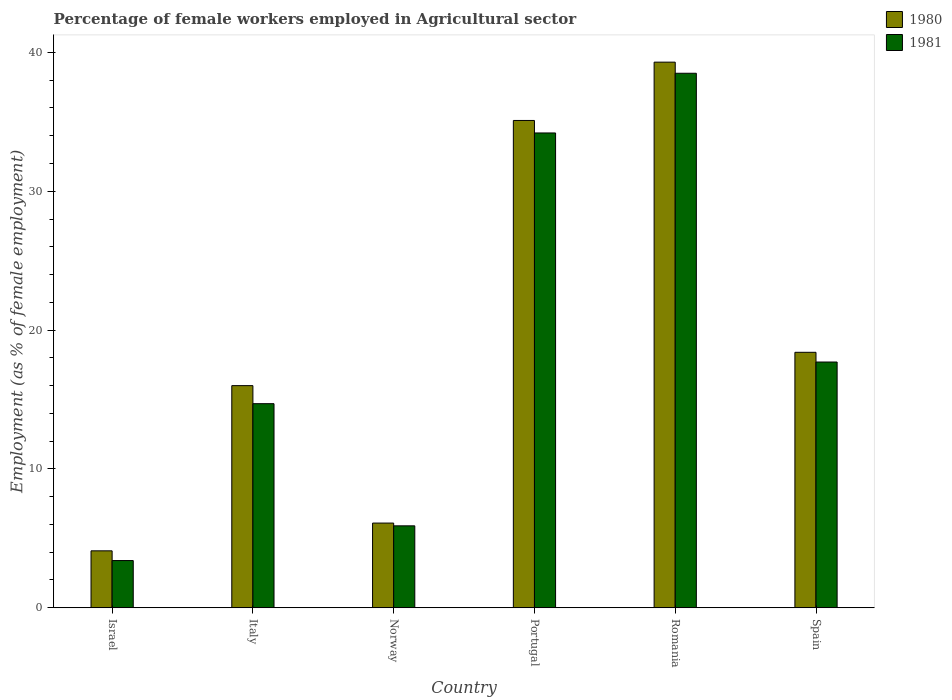Are the number of bars per tick equal to the number of legend labels?
Give a very brief answer. Yes. What is the label of the 4th group of bars from the left?
Offer a terse response. Portugal. What is the percentage of females employed in Agricultural sector in 1981 in Romania?
Make the answer very short. 38.5. Across all countries, what is the maximum percentage of females employed in Agricultural sector in 1981?
Keep it short and to the point. 38.5. Across all countries, what is the minimum percentage of females employed in Agricultural sector in 1980?
Keep it short and to the point. 4.1. In which country was the percentage of females employed in Agricultural sector in 1980 maximum?
Keep it short and to the point. Romania. What is the total percentage of females employed in Agricultural sector in 1980 in the graph?
Offer a very short reply. 119. What is the difference between the percentage of females employed in Agricultural sector in 1980 in Italy and that in Norway?
Your answer should be very brief. 9.9. What is the difference between the percentage of females employed in Agricultural sector in 1980 in Romania and the percentage of females employed in Agricultural sector in 1981 in Norway?
Your response must be concise. 33.4. What is the average percentage of females employed in Agricultural sector in 1981 per country?
Give a very brief answer. 19.07. What is the difference between the percentage of females employed in Agricultural sector of/in 1980 and percentage of females employed in Agricultural sector of/in 1981 in Spain?
Give a very brief answer. 0.7. What is the ratio of the percentage of females employed in Agricultural sector in 1981 in Italy to that in Portugal?
Provide a succinct answer. 0.43. Is the percentage of females employed in Agricultural sector in 1981 in Israel less than that in Italy?
Ensure brevity in your answer.  Yes. What is the difference between the highest and the second highest percentage of females employed in Agricultural sector in 1980?
Provide a succinct answer. -16.7. What is the difference between the highest and the lowest percentage of females employed in Agricultural sector in 1980?
Provide a short and direct response. 35.2. What does the 2nd bar from the left in Italy represents?
Your answer should be very brief. 1981. What does the 2nd bar from the right in Romania represents?
Your answer should be compact. 1980. Are all the bars in the graph horizontal?
Your answer should be compact. No. How many countries are there in the graph?
Provide a short and direct response. 6. What is the difference between two consecutive major ticks on the Y-axis?
Provide a succinct answer. 10. Does the graph contain any zero values?
Offer a very short reply. No. Where does the legend appear in the graph?
Give a very brief answer. Top right. How many legend labels are there?
Ensure brevity in your answer.  2. What is the title of the graph?
Ensure brevity in your answer.  Percentage of female workers employed in Agricultural sector. Does "1974" appear as one of the legend labels in the graph?
Offer a terse response. No. What is the label or title of the X-axis?
Offer a very short reply. Country. What is the label or title of the Y-axis?
Your answer should be compact. Employment (as % of female employment). What is the Employment (as % of female employment) in 1980 in Israel?
Your answer should be very brief. 4.1. What is the Employment (as % of female employment) of 1981 in Israel?
Ensure brevity in your answer.  3.4. What is the Employment (as % of female employment) of 1981 in Italy?
Your response must be concise. 14.7. What is the Employment (as % of female employment) in 1980 in Norway?
Your response must be concise. 6.1. What is the Employment (as % of female employment) in 1981 in Norway?
Give a very brief answer. 5.9. What is the Employment (as % of female employment) in 1980 in Portugal?
Offer a very short reply. 35.1. What is the Employment (as % of female employment) of 1981 in Portugal?
Provide a short and direct response. 34.2. What is the Employment (as % of female employment) in 1980 in Romania?
Offer a terse response. 39.3. What is the Employment (as % of female employment) in 1981 in Romania?
Make the answer very short. 38.5. What is the Employment (as % of female employment) in 1980 in Spain?
Keep it short and to the point. 18.4. What is the Employment (as % of female employment) in 1981 in Spain?
Keep it short and to the point. 17.7. Across all countries, what is the maximum Employment (as % of female employment) of 1980?
Provide a short and direct response. 39.3. Across all countries, what is the maximum Employment (as % of female employment) in 1981?
Your answer should be compact. 38.5. Across all countries, what is the minimum Employment (as % of female employment) in 1980?
Your answer should be very brief. 4.1. Across all countries, what is the minimum Employment (as % of female employment) in 1981?
Your answer should be very brief. 3.4. What is the total Employment (as % of female employment) in 1980 in the graph?
Your answer should be compact. 119. What is the total Employment (as % of female employment) in 1981 in the graph?
Give a very brief answer. 114.4. What is the difference between the Employment (as % of female employment) in 1980 in Israel and that in Italy?
Give a very brief answer. -11.9. What is the difference between the Employment (as % of female employment) of 1981 in Israel and that in Norway?
Your answer should be compact. -2.5. What is the difference between the Employment (as % of female employment) of 1980 in Israel and that in Portugal?
Ensure brevity in your answer.  -31. What is the difference between the Employment (as % of female employment) in 1981 in Israel and that in Portugal?
Your answer should be very brief. -30.8. What is the difference between the Employment (as % of female employment) of 1980 in Israel and that in Romania?
Keep it short and to the point. -35.2. What is the difference between the Employment (as % of female employment) in 1981 in Israel and that in Romania?
Your answer should be very brief. -35.1. What is the difference between the Employment (as % of female employment) of 1980 in Israel and that in Spain?
Make the answer very short. -14.3. What is the difference between the Employment (as % of female employment) in 1981 in Israel and that in Spain?
Provide a short and direct response. -14.3. What is the difference between the Employment (as % of female employment) in 1980 in Italy and that in Norway?
Your answer should be very brief. 9.9. What is the difference between the Employment (as % of female employment) of 1981 in Italy and that in Norway?
Your answer should be very brief. 8.8. What is the difference between the Employment (as % of female employment) in 1980 in Italy and that in Portugal?
Offer a very short reply. -19.1. What is the difference between the Employment (as % of female employment) in 1981 in Italy and that in Portugal?
Offer a very short reply. -19.5. What is the difference between the Employment (as % of female employment) in 1980 in Italy and that in Romania?
Provide a short and direct response. -23.3. What is the difference between the Employment (as % of female employment) in 1981 in Italy and that in Romania?
Offer a very short reply. -23.8. What is the difference between the Employment (as % of female employment) in 1980 in Italy and that in Spain?
Give a very brief answer. -2.4. What is the difference between the Employment (as % of female employment) in 1981 in Italy and that in Spain?
Ensure brevity in your answer.  -3. What is the difference between the Employment (as % of female employment) of 1981 in Norway and that in Portugal?
Provide a succinct answer. -28.3. What is the difference between the Employment (as % of female employment) in 1980 in Norway and that in Romania?
Make the answer very short. -33.2. What is the difference between the Employment (as % of female employment) of 1981 in Norway and that in Romania?
Keep it short and to the point. -32.6. What is the difference between the Employment (as % of female employment) in 1980 in Norway and that in Spain?
Your response must be concise. -12.3. What is the difference between the Employment (as % of female employment) of 1981 in Norway and that in Spain?
Offer a very short reply. -11.8. What is the difference between the Employment (as % of female employment) in 1980 in Portugal and that in Romania?
Your response must be concise. -4.2. What is the difference between the Employment (as % of female employment) in 1980 in Romania and that in Spain?
Offer a very short reply. 20.9. What is the difference between the Employment (as % of female employment) of 1981 in Romania and that in Spain?
Keep it short and to the point. 20.8. What is the difference between the Employment (as % of female employment) in 1980 in Israel and the Employment (as % of female employment) in 1981 in Norway?
Keep it short and to the point. -1.8. What is the difference between the Employment (as % of female employment) in 1980 in Israel and the Employment (as % of female employment) in 1981 in Portugal?
Offer a terse response. -30.1. What is the difference between the Employment (as % of female employment) in 1980 in Israel and the Employment (as % of female employment) in 1981 in Romania?
Keep it short and to the point. -34.4. What is the difference between the Employment (as % of female employment) in 1980 in Israel and the Employment (as % of female employment) in 1981 in Spain?
Give a very brief answer. -13.6. What is the difference between the Employment (as % of female employment) in 1980 in Italy and the Employment (as % of female employment) in 1981 in Portugal?
Ensure brevity in your answer.  -18.2. What is the difference between the Employment (as % of female employment) in 1980 in Italy and the Employment (as % of female employment) in 1981 in Romania?
Provide a succinct answer. -22.5. What is the difference between the Employment (as % of female employment) in 1980 in Norway and the Employment (as % of female employment) in 1981 in Portugal?
Offer a very short reply. -28.1. What is the difference between the Employment (as % of female employment) in 1980 in Norway and the Employment (as % of female employment) in 1981 in Romania?
Your response must be concise. -32.4. What is the difference between the Employment (as % of female employment) in 1980 in Portugal and the Employment (as % of female employment) in 1981 in Romania?
Ensure brevity in your answer.  -3.4. What is the difference between the Employment (as % of female employment) of 1980 in Portugal and the Employment (as % of female employment) of 1981 in Spain?
Offer a very short reply. 17.4. What is the difference between the Employment (as % of female employment) in 1980 in Romania and the Employment (as % of female employment) in 1981 in Spain?
Your answer should be very brief. 21.6. What is the average Employment (as % of female employment) of 1980 per country?
Offer a terse response. 19.83. What is the average Employment (as % of female employment) in 1981 per country?
Offer a very short reply. 19.07. What is the difference between the Employment (as % of female employment) in 1980 and Employment (as % of female employment) in 1981 in Italy?
Provide a succinct answer. 1.3. What is the difference between the Employment (as % of female employment) in 1980 and Employment (as % of female employment) in 1981 in Portugal?
Offer a terse response. 0.9. What is the ratio of the Employment (as % of female employment) of 1980 in Israel to that in Italy?
Your response must be concise. 0.26. What is the ratio of the Employment (as % of female employment) of 1981 in Israel to that in Italy?
Provide a succinct answer. 0.23. What is the ratio of the Employment (as % of female employment) of 1980 in Israel to that in Norway?
Provide a short and direct response. 0.67. What is the ratio of the Employment (as % of female employment) of 1981 in Israel to that in Norway?
Offer a terse response. 0.58. What is the ratio of the Employment (as % of female employment) of 1980 in Israel to that in Portugal?
Provide a short and direct response. 0.12. What is the ratio of the Employment (as % of female employment) in 1981 in Israel to that in Portugal?
Ensure brevity in your answer.  0.1. What is the ratio of the Employment (as % of female employment) in 1980 in Israel to that in Romania?
Keep it short and to the point. 0.1. What is the ratio of the Employment (as % of female employment) of 1981 in Israel to that in Romania?
Ensure brevity in your answer.  0.09. What is the ratio of the Employment (as % of female employment) of 1980 in Israel to that in Spain?
Ensure brevity in your answer.  0.22. What is the ratio of the Employment (as % of female employment) of 1981 in Israel to that in Spain?
Provide a succinct answer. 0.19. What is the ratio of the Employment (as % of female employment) in 1980 in Italy to that in Norway?
Provide a succinct answer. 2.62. What is the ratio of the Employment (as % of female employment) of 1981 in Italy to that in Norway?
Your answer should be compact. 2.49. What is the ratio of the Employment (as % of female employment) of 1980 in Italy to that in Portugal?
Provide a succinct answer. 0.46. What is the ratio of the Employment (as % of female employment) of 1981 in Italy to that in Portugal?
Make the answer very short. 0.43. What is the ratio of the Employment (as % of female employment) in 1980 in Italy to that in Romania?
Ensure brevity in your answer.  0.41. What is the ratio of the Employment (as % of female employment) of 1981 in Italy to that in Romania?
Your answer should be very brief. 0.38. What is the ratio of the Employment (as % of female employment) of 1980 in Italy to that in Spain?
Provide a succinct answer. 0.87. What is the ratio of the Employment (as % of female employment) of 1981 in Italy to that in Spain?
Your answer should be very brief. 0.83. What is the ratio of the Employment (as % of female employment) in 1980 in Norway to that in Portugal?
Give a very brief answer. 0.17. What is the ratio of the Employment (as % of female employment) of 1981 in Norway to that in Portugal?
Provide a short and direct response. 0.17. What is the ratio of the Employment (as % of female employment) in 1980 in Norway to that in Romania?
Your response must be concise. 0.16. What is the ratio of the Employment (as % of female employment) in 1981 in Norway to that in Romania?
Offer a very short reply. 0.15. What is the ratio of the Employment (as % of female employment) in 1980 in Norway to that in Spain?
Keep it short and to the point. 0.33. What is the ratio of the Employment (as % of female employment) of 1980 in Portugal to that in Romania?
Your answer should be very brief. 0.89. What is the ratio of the Employment (as % of female employment) of 1981 in Portugal to that in Romania?
Ensure brevity in your answer.  0.89. What is the ratio of the Employment (as % of female employment) in 1980 in Portugal to that in Spain?
Your answer should be compact. 1.91. What is the ratio of the Employment (as % of female employment) in 1981 in Portugal to that in Spain?
Provide a succinct answer. 1.93. What is the ratio of the Employment (as % of female employment) in 1980 in Romania to that in Spain?
Offer a very short reply. 2.14. What is the ratio of the Employment (as % of female employment) of 1981 in Romania to that in Spain?
Give a very brief answer. 2.18. What is the difference between the highest and the second highest Employment (as % of female employment) in 1980?
Your response must be concise. 4.2. What is the difference between the highest and the lowest Employment (as % of female employment) in 1980?
Your answer should be compact. 35.2. What is the difference between the highest and the lowest Employment (as % of female employment) in 1981?
Your answer should be compact. 35.1. 